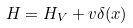<formula> <loc_0><loc_0><loc_500><loc_500>H = H _ { V } + v \delta ( x )</formula> 